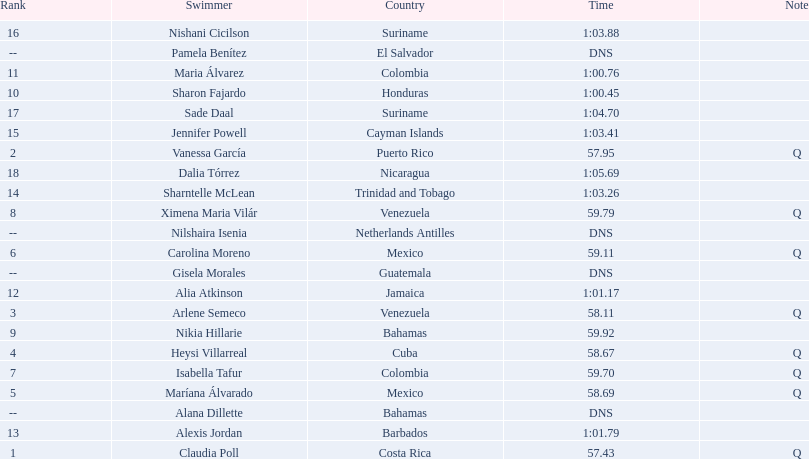How many swimmers recorded a minimum time of 1:00? 9. 